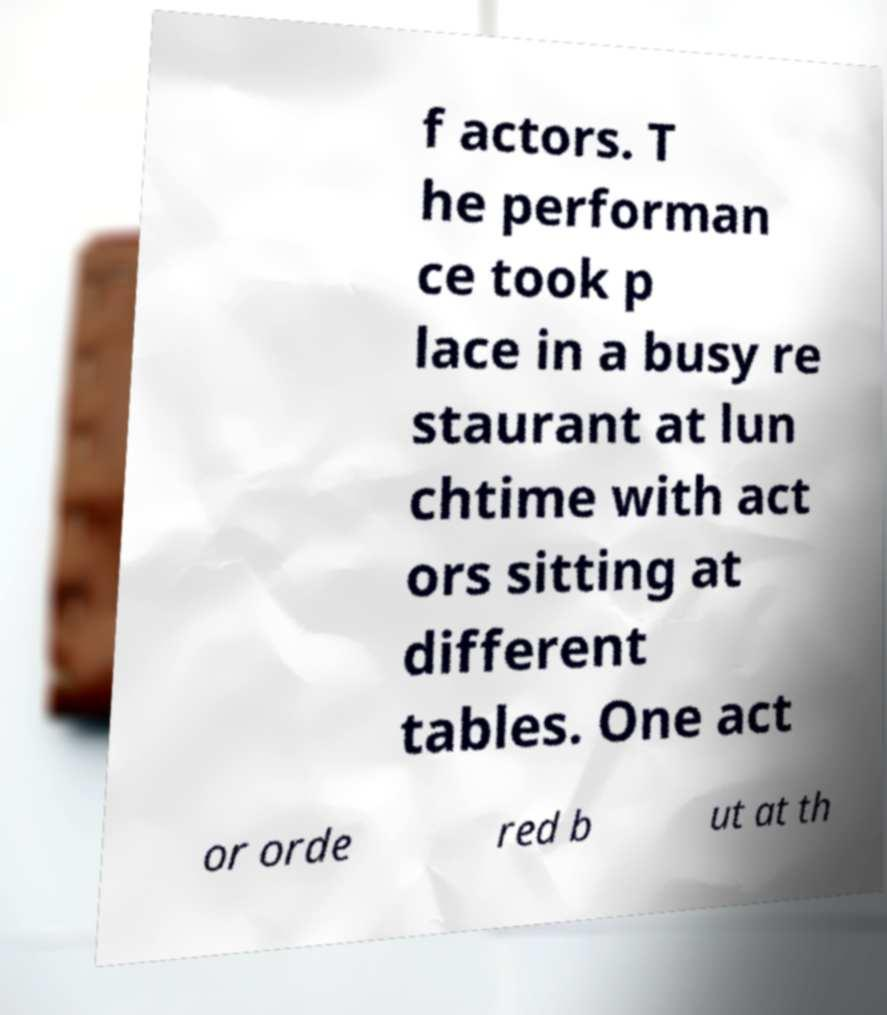There's text embedded in this image that I need extracted. Can you transcribe it verbatim? f actors. T he performan ce took p lace in a busy re staurant at lun chtime with act ors sitting at different tables. One act or orde red b ut at th 